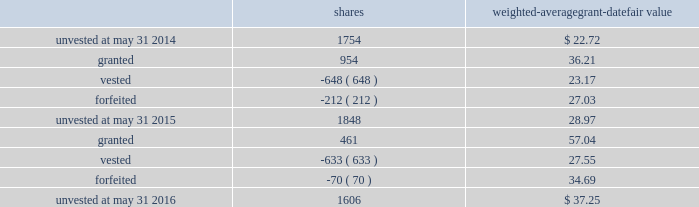Leveraged performance units during fiscal 2015 , certain executives were granted performance units that we refer to as leveraged performance units , or lpus .
Lpus contain a market condition based on our relative stock price growth over a three-year performance period .
The lpus contain a minimum threshold performance which , if not met , would result in no payout .
The lpus also contain a maximum award opportunity set as a fixed dollar and fixed number of shares .
After the three-year performance period , one-third of any earned units converts to unrestricted common stock .
The remaining two-thirds convert to restricted stock that will vest in equal installments on each of the first two anniversaries of the conversion date .
We recognize share-based compensation expense based on the grant date fair value of the lpus , as determined by use of a monte carlo model , on a straight-line basis over the requisite service period for each separately vesting portion of the lpu award .
Total shareholder return units before fiscal 2015 , certain of our executives were granted total shareholder return ( 201ctsr 201d ) units , which are performance-based restricted stock units that are earned based on our total shareholder return over a three-year performance period compared to companies in the s&p 500 .
Once the performance results are certified , tsr units convert into unrestricted common stock .
Depending on our performance , the grantee may earn up to 200% ( 200 % ) of the target number of shares .
The target number of tsr units for each executive is set by the compensation committee .
We recognize share-based compensation expense based on the grant date fair value of the tsr units , as determined by use of a monte carlo model , on a straight-line basis over the vesting period .
The table summarizes the changes in unvested share-based awards for the years ended may 31 , 2016 and 2015 ( shares in thousands ) : shares weighted-average grant-date fair value .
Including the restricted stock , performance units and tsr units described above , the total fair value of share- based awards vested during the years ended may 31 , 2016 , 2015 and 2014 was $ 17.4 million , $ 15.0 million and $ 28.7 million , respectively .
For these share-based awards , we recognized compensation expense of $ 28.8 million , $ 19.8 million and $ 28.2 million in the years ended may 31 , 2016 , 2015 and 2014 , respectively .
As of may 31 , 2016 , there was $ 42.6 million of unrecognized compensation expense related to unvested share-based awards that we expect to recognize over a weighted-average period of 1.9 years .
Our share-based award plans provide for accelerated vesting under certain conditions .
Employee stock purchase plan we have an employee stock purchase plan under which the sale of 4.8 million shares of our common stock has been authorized .
Employees may designate up to the lesser of $ 25000 or 20% ( 20 % ) of their annual compensation for the purchase of our common stock .
The price for shares purchased under the plan is 85% ( 85 % ) of the market value on 84 2013 global payments inc .
| 2016 form 10-k annual report .
What was the average unrecognized compensation expense related to unvested share-based per year? 
Rationale: to find the average per year one must take the total and divide that by the amount of years .
Computations: (42.6 / 1.9)
Answer: 22.42105. 